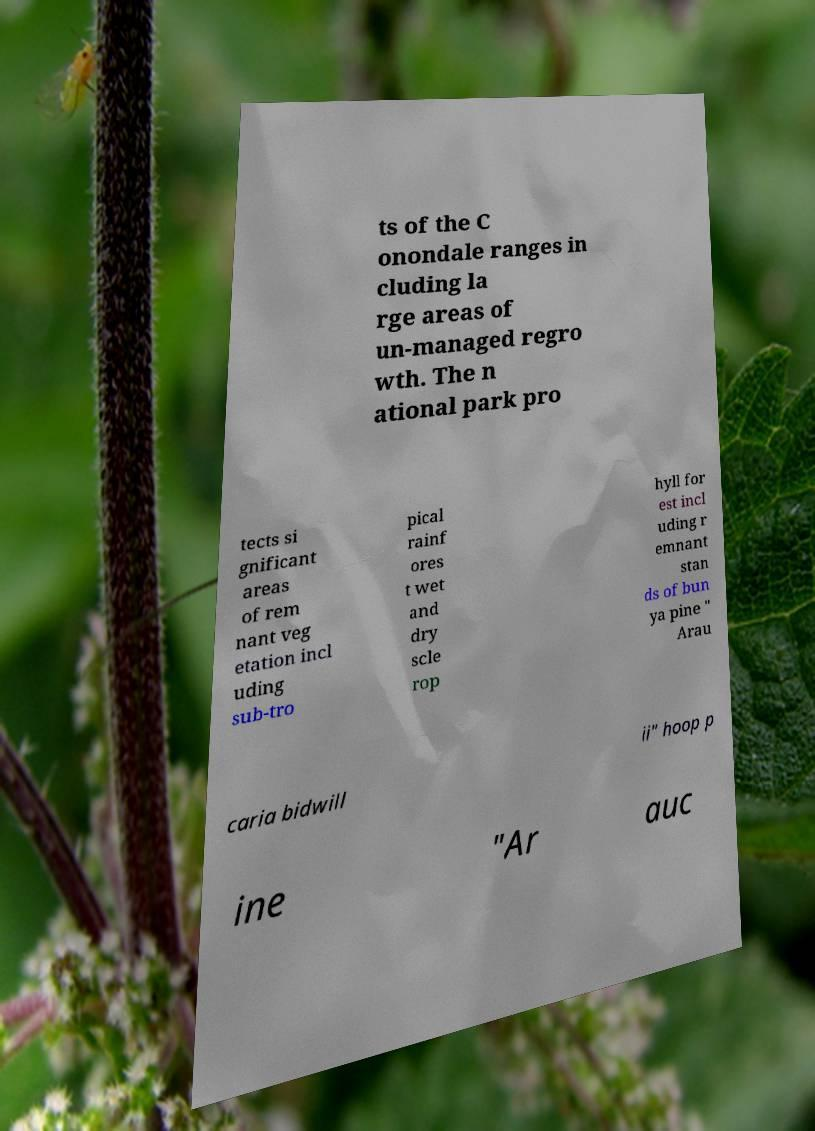For documentation purposes, I need the text within this image transcribed. Could you provide that? ts of the C onondale ranges in cluding la rge areas of un-managed regro wth. The n ational park pro tects si gnificant areas of rem nant veg etation incl uding sub-tro pical rainf ores t wet and dry scle rop hyll for est incl uding r emnant stan ds of bun ya pine " Arau caria bidwill ii" hoop p ine "Ar auc 